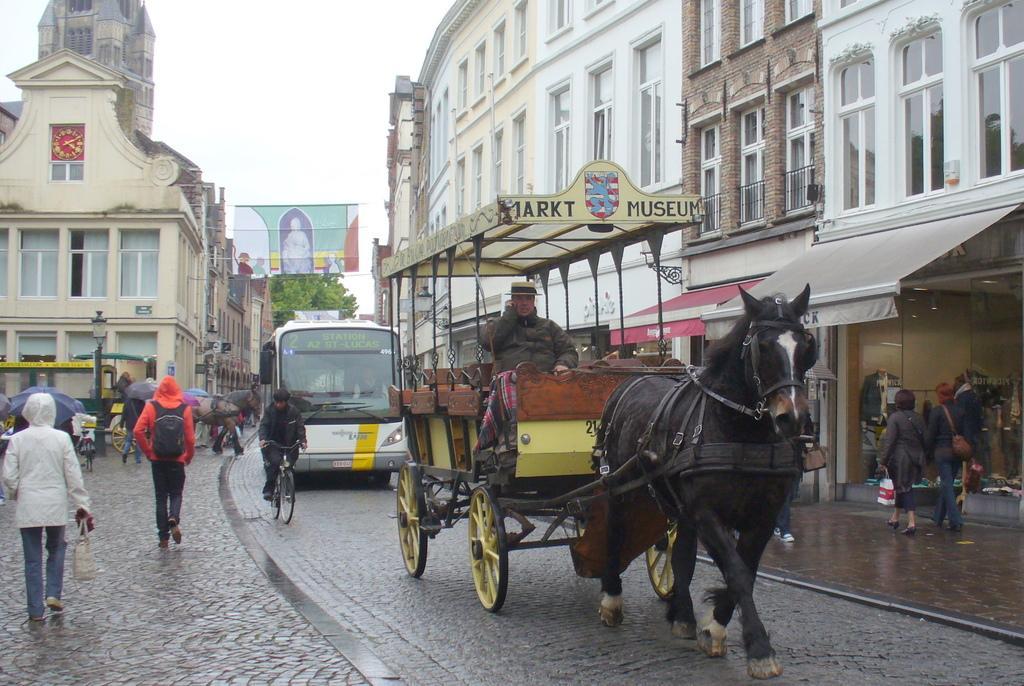Can you describe this image briefly? In this picture I can see horse cart on which a person is sitting on it. In the background I can see buildings, tree, people, vehicles, bicycle and street lights. I can also see a banner and sky. Some people are holding umbrellas. 